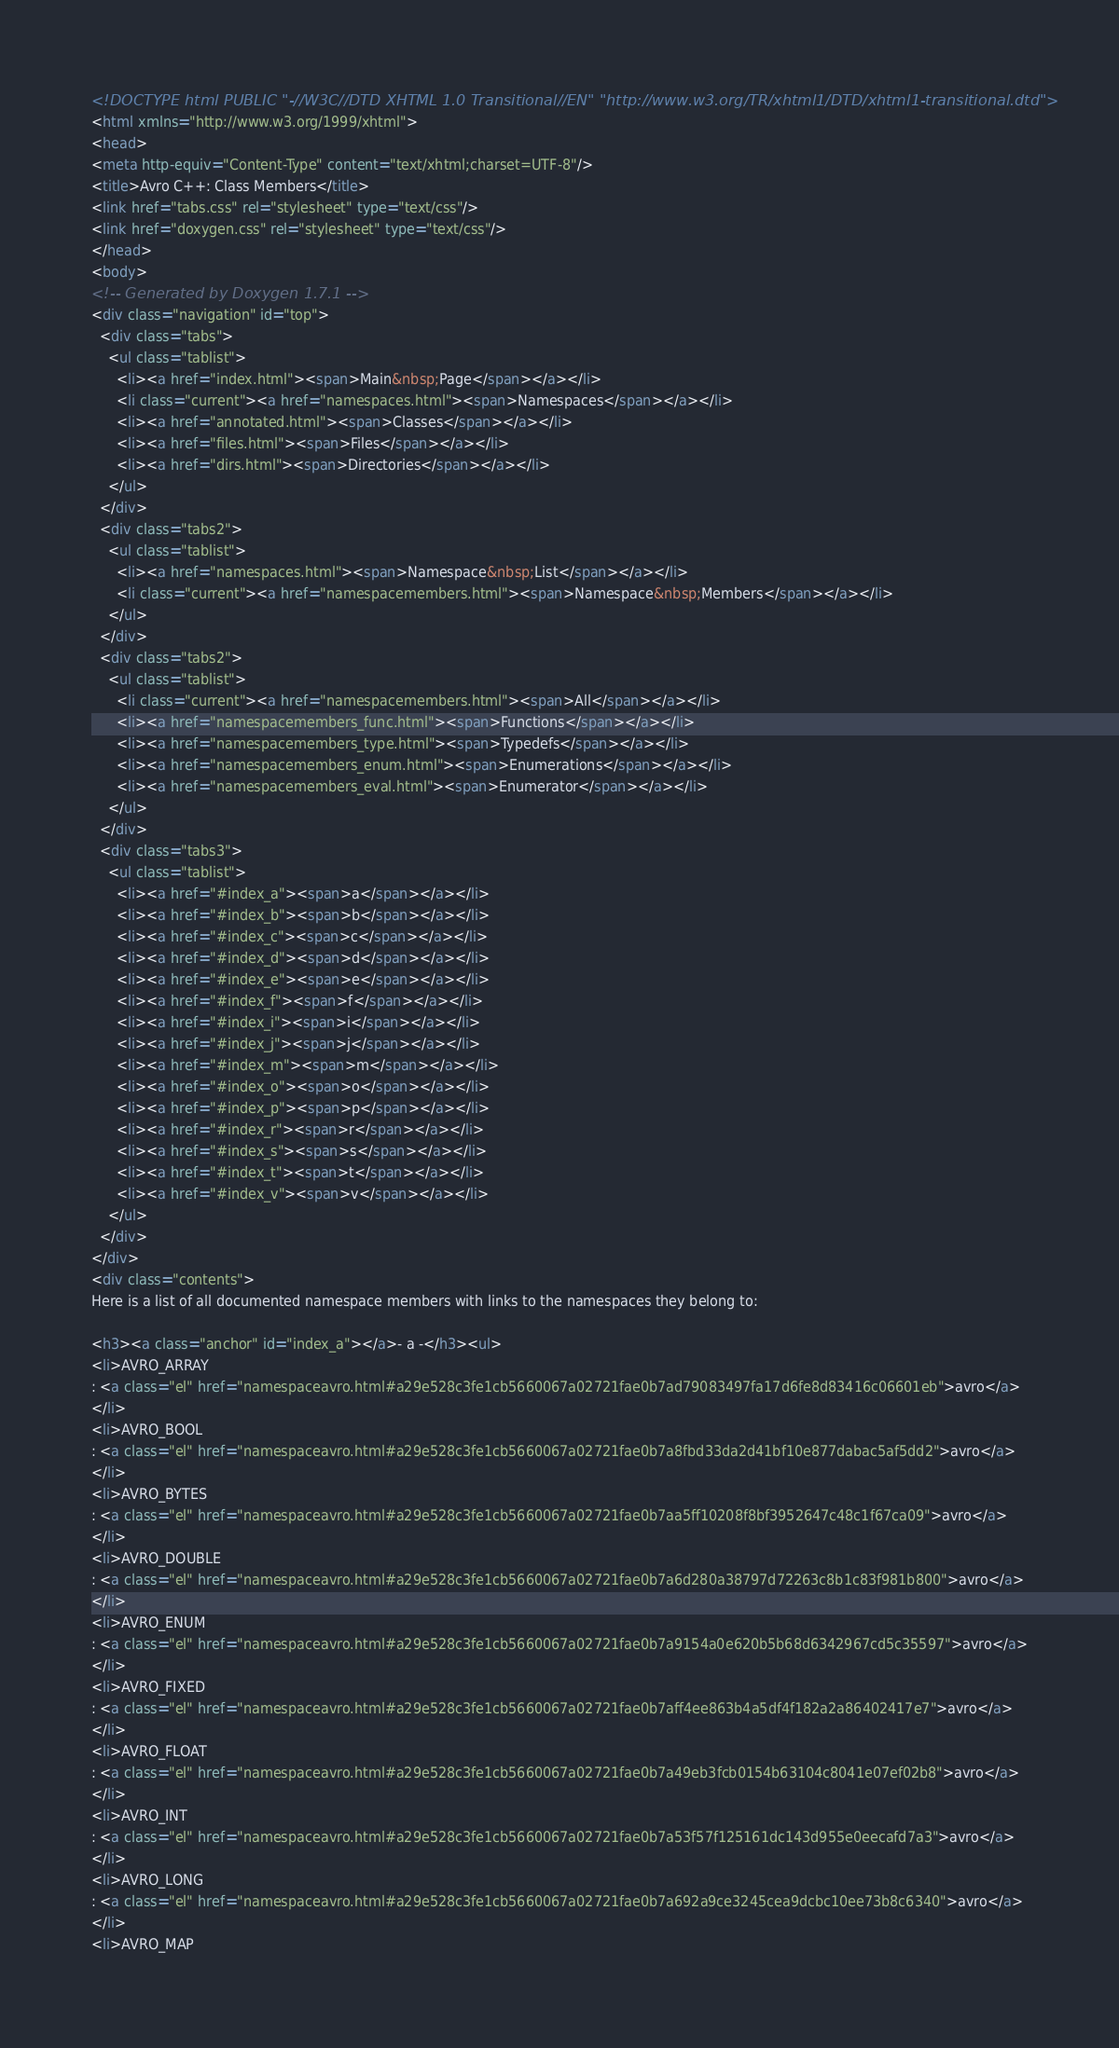Convert code to text. <code><loc_0><loc_0><loc_500><loc_500><_HTML_><!DOCTYPE html PUBLIC "-//W3C//DTD XHTML 1.0 Transitional//EN" "http://www.w3.org/TR/xhtml1/DTD/xhtml1-transitional.dtd">
<html xmlns="http://www.w3.org/1999/xhtml">
<head>
<meta http-equiv="Content-Type" content="text/xhtml;charset=UTF-8"/>
<title>Avro C++: Class Members</title>
<link href="tabs.css" rel="stylesheet" type="text/css"/>
<link href="doxygen.css" rel="stylesheet" type="text/css"/>
</head>
<body>
<!-- Generated by Doxygen 1.7.1 -->
<div class="navigation" id="top">
  <div class="tabs">
    <ul class="tablist">
      <li><a href="index.html"><span>Main&nbsp;Page</span></a></li>
      <li class="current"><a href="namespaces.html"><span>Namespaces</span></a></li>
      <li><a href="annotated.html"><span>Classes</span></a></li>
      <li><a href="files.html"><span>Files</span></a></li>
      <li><a href="dirs.html"><span>Directories</span></a></li>
    </ul>
  </div>
  <div class="tabs2">
    <ul class="tablist">
      <li><a href="namespaces.html"><span>Namespace&nbsp;List</span></a></li>
      <li class="current"><a href="namespacemembers.html"><span>Namespace&nbsp;Members</span></a></li>
    </ul>
  </div>
  <div class="tabs2">
    <ul class="tablist">
      <li class="current"><a href="namespacemembers.html"><span>All</span></a></li>
      <li><a href="namespacemembers_func.html"><span>Functions</span></a></li>
      <li><a href="namespacemembers_type.html"><span>Typedefs</span></a></li>
      <li><a href="namespacemembers_enum.html"><span>Enumerations</span></a></li>
      <li><a href="namespacemembers_eval.html"><span>Enumerator</span></a></li>
    </ul>
  </div>
  <div class="tabs3">
    <ul class="tablist">
      <li><a href="#index_a"><span>a</span></a></li>
      <li><a href="#index_b"><span>b</span></a></li>
      <li><a href="#index_c"><span>c</span></a></li>
      <li><a href="#index_d"><span>d</span></a></li>
      <li><a href="#index_e"><span>e</span></a></li>
      <li><a href="#index_f"><span>f</span></a></li>
      <li><a href="#index_i"><span>i</span></a></li>
      <li><a href="#index_j"><span>j</span></a></li>
      <li><a href="#index_m"><span>m</span></a></li>
      <li><a href="#index_o"><span>o</span></a></li>
      <li><a href="#index_p"><span>p</span></a></li>
      <li><a href="#index_r"><span>r</span></a></li>
      <li><a href="#index_s"><span>s</span></a></li>
      <li><a href="#index_t"><span>t</span></a></li>
      <li><a href="#index_v"><span>v</span></a></li>
    </ul>
  </div>
</div>
<div class="contents">
Here is a list of all documented namespace members with links to the namespaces they belong to:

<h3><a class="anchor" id="index_a"></a>- a -</h3><ul>
<li>AVRO_ARRAY
: <a class="el" href="namespaceavro.html#a29e528c3fe1cb5660067a02721fae0b7ad79083497fa17d6fe8d83416c06601eb">avro</a>
</li>
<li>AVRO_BOOL
: <a class="el" href="namespaceavro.html#a29e528c3fe1cb5660067a02721fae0b7a8fbd33da2d41bf10e877dabac5af5dd2">avro</a>
</li>
<li>AVRO_BYTES
: <a class="el" href="namespaceavro.html#a29e528c3fe1cb5660067a02721fae0b7aa5ff10208f8bf3952647c48c1f67ca09">avro</a>
</li>
<li>AVRO_DOUBLE
: <a class="el" href="namespaceavro.html#a29e528c3fe1cb5660067a02721fae0b7a6d280a38797d72263c8b1c83f981b800">avro</a>
</li>
<li>AVRO_ENUM
: <a class="el" href="namespaceavro.html#a29e528c3fe1cb5660067a02721fae0b7a9154a0e620b5b68d6342967cd5c35597">avro</a>
</li>
<li>AVRO_FIXED
: <a class="el" href="namespaceavro.html#a29e528c3fe1cb5660067a02721fae0b7aff4ee863b4a5df4f182a2a86402417e7">avro</a>
</li>
<li>AVRO_FLOAT
: <a class="el" href="namespaceavro.html#a29e528c3fe1cb5660067a02721fae0b7a49eb3fcb0154b63104c8041e07ef02b8">avro</a>
</li>
<li>AVRO_INT
: <a class="el" href="namespaceavro.html#a29e528c3fe1cb5660067a02721fae0b7a53f57f125161dc143d955e0eecafd7a3">avro</a>
</li>
<li>AVRO_LONG
: <a class="el" href="namespaceavro.html#a29e528c3fe1cb5660067a02721fae0b7a692a9ce3245cea9dcbc10ee73b8c6340">avro</a>
</li>
<li>AVRO_MAP</code> 